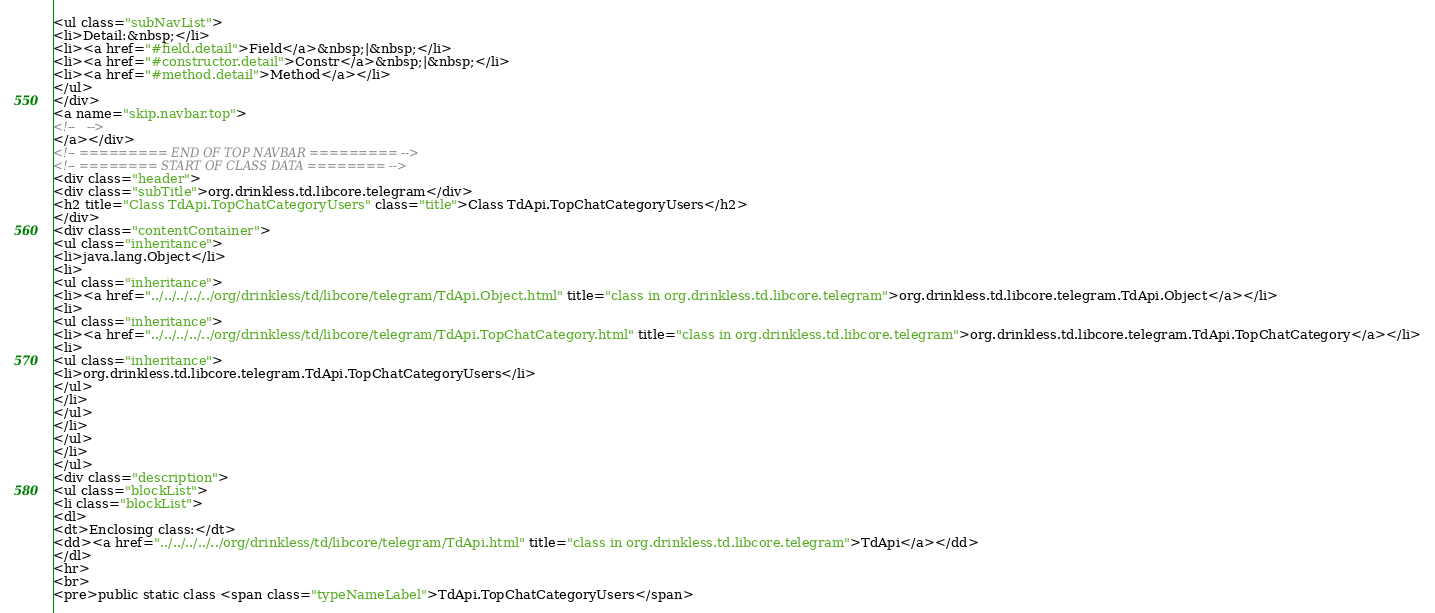Convert code to text. <code><loc_0><loc_0><loc_500><loc_500><_HTML_><ul class="subNavList">
<li>Detail:&nbsp;</li>
<li><a href="#field.detail">Field</a>&nbsp;|&nbsp;</li>
<li><a href="#constructor.detail">Constr</a>&nbsp;|&nbsp;</li>
<li><a href="#method.detail">Method</a></li>
</ul>
</div>
<a name="skip.navbar.top">
<!--   -->
</a></div>
<!-- ========= END OF TOP NAVBAR ========= -->
<!-- ======== START OF CLASS DATA ======== -->
<div class="header">
<div class="subTitle">org.drinkless.td.libcore.telegram</div>
<h2 title="Class TdApi.TopChatCategoryUsers" class="title">Class TdApi.TopChatCategoryUsers</h2>
</div>
<div class="contentContainer">
<ul class="inheritance">
<li>java.lang.Object</li>
<li>
<ul class="inheritance">
<li><a href="../../../../../org/drinkless/td/libcore/telegram/TdApi.Object.html" title="class in org.drinkless.td.libcore.telegram">org.drinkless.td.libcore.telegram.TdApi.Object</a></li>
<li>
<ul class="inheritance">
<li><a href="../../../../../org/drinkless/td/libcore/telegram/TdApi.TopChatCategory.html" title="class in org.drinkless.td.libcore.telegram">org.drinkless.td.libcore.telegram.TdApi.TopChatCategory</a></li>
<li>
<ul class="inheritance">
<li>org.drinkless.td.libcore.telegram.TdApi.TopChatCategoryUsers</li>
</ul>
</li>
</ul>
</li>
</ul>
</li>
</ul>
<div class="description">
<ul class="blockList">
<li class="blockList">
<dl>
<dt>Enclosing class:</dt>
<dd><a href="../../../../../org/drinkless/td/libcore/telegram/TdApi.html" title="class in org.drinkless.td.libcore.telegram">TdApi</a></dd>
</dl>
<hr>
<br>
<pre>public static class <span class="typeNameLabel">TdApi.TopChatCategoryUsers</span></code> 